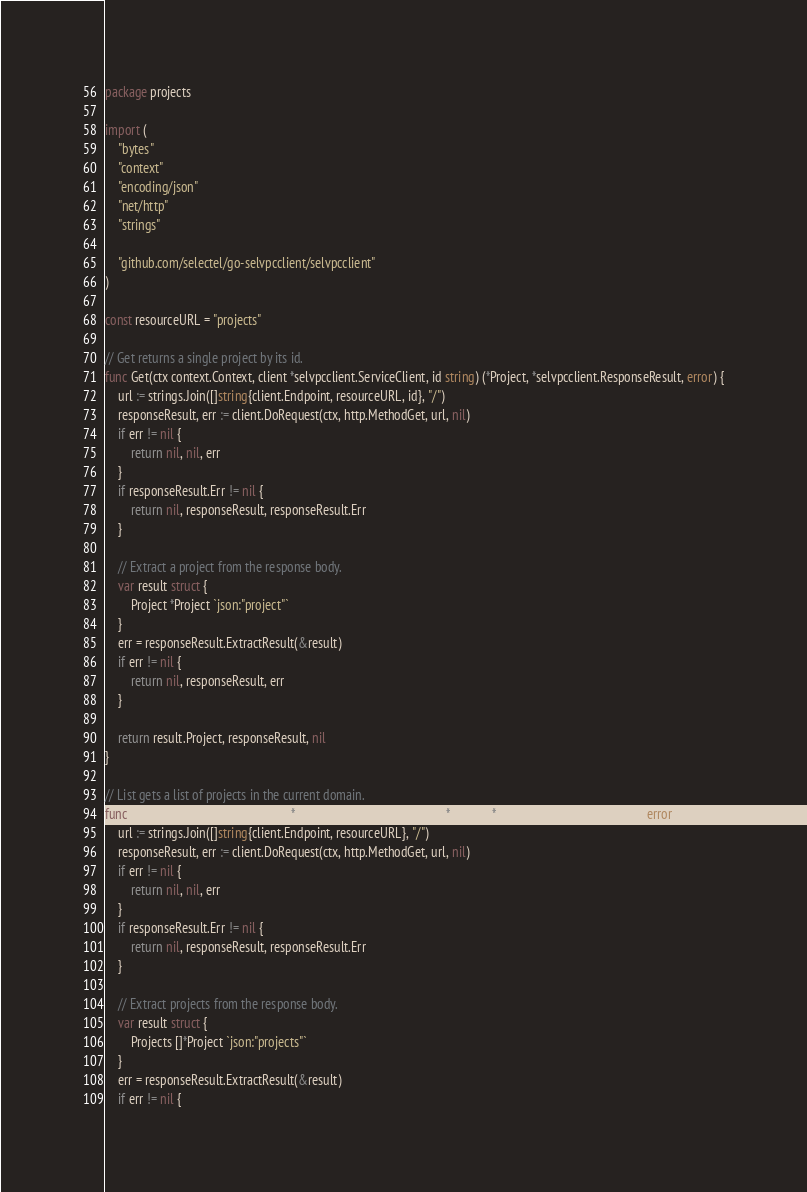<code> <loc_0><loc_0><loc_500><loc_500><_Go_>package projects

import (
	"bytes"
	"context"
	"encoding/json"
	"net/http"
	"strings"

	"github.com/selectel/go-selvpcclient/selvpcclient"
)

const resourceURL = "projects"

// Get returns a single project by its id.
func Get(ctx context.Context, client *selvpcclient.ServiceClient, id string) (*Project, *selvpcclient.ResponseResult, error) {
	url := strings.Join([]string{client.Endpoint, resourceURL, id}, "/")
	responseResult, err := client.DoRequest(ctx, http.MethodGet, url, nil)
	if err != nil {
		return nil, nil, err
	}
	if responseResult.Err != nil {
		return nil, responseResult, responseResult.Err
	}

	// Extract a project from the response body.
	var result struct {
		Project *Project `json:"project"`
	}
	err = responseResult.ExtractResult(&result)
	if err != nil {
		return nil, responseResult, err
	}

	return result.Project, responseResult, nil
}

// List gets a list of projects in the current domain.
func List(ctx context.Context, client *selvpcclient.ServiceClient) ([]*Project, *selvpcclient.ResponseResult, error) {
	url := strings.Join([]string{client.Endpoint, resourceURL}, "/")
	responseResult, err := client.DoRequest(ctx, http.MethodGet, url, nil)
	if err != nil {
		return nil, nil, err
	}
	if responseResult.Err != nil {
		return nil, responseResult, responseResult.Err
	}

	// Extract projects from the response body.
	var result struct {
		Projects []*Project `json:"projects"`
	}
	err = responseResult.ExtractResult(&result)
	if err != nil {</code> 